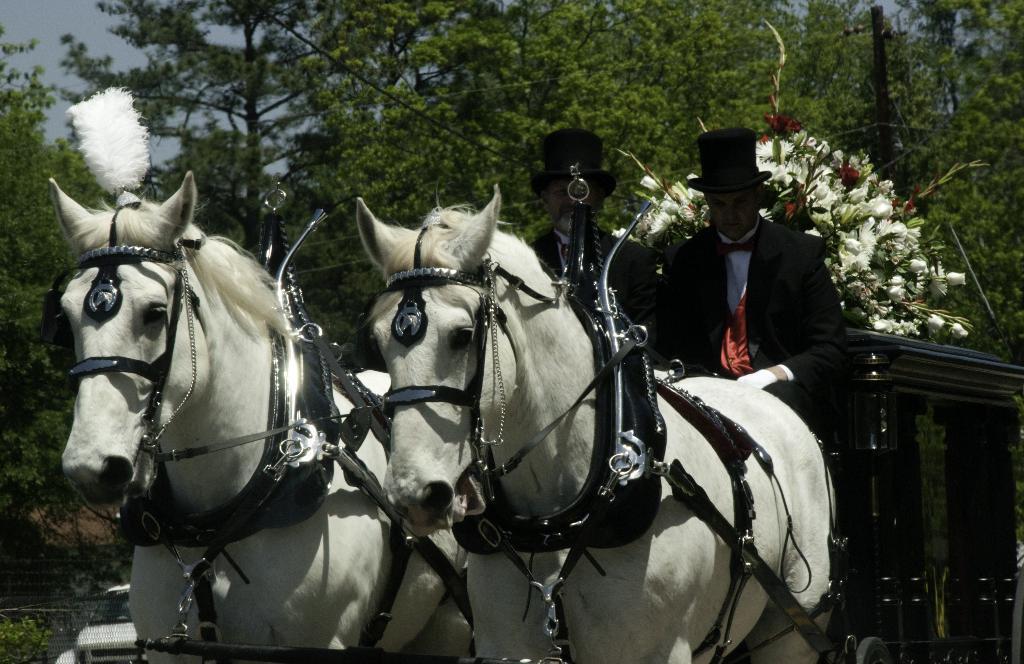How would you summarize this image in a sentence or two? In this image I can see a two horse which is in white color. There are two person is siting on the vehicle. He is wearing a black coat and a black hat with a red bow. At the back side we can see trees. At the back of the person we can see a flower bouquet. 